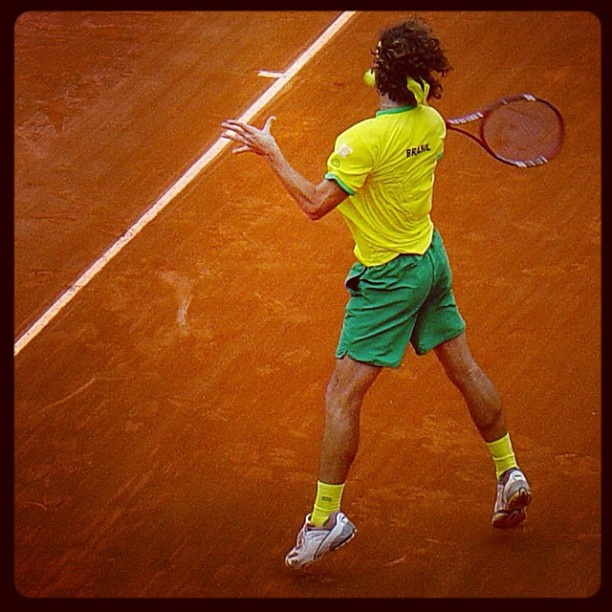Describe the objects in this image and their specific colors. I can see people in black, brown, maroon, and olive tones, tennis racket in black, brown, and maroon tones, and sports ball in black, olive, and khaki tones in this image. 